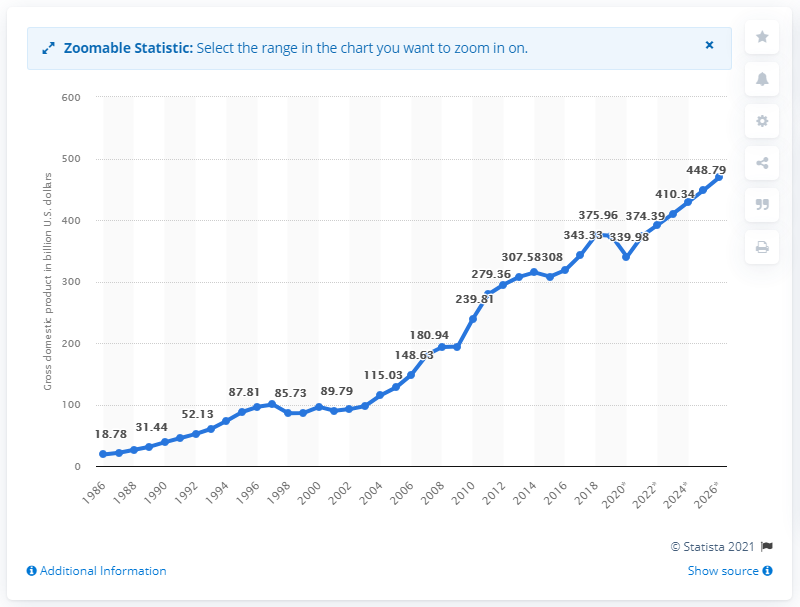List a handful of essential elements in this visual. In 2019, Singapore's gross domestic product (GDP) was 374.39. 